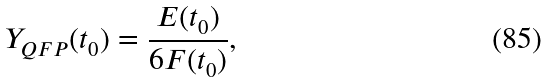<formula> <loc_0><loc_0><loc_500><loc_500>Y _ { Q F P } ( t _ { 0 } ) = \frac { E ( t _ { 0 } ) } { 6 F ( t _ { 0 } ) } ,</formula> 